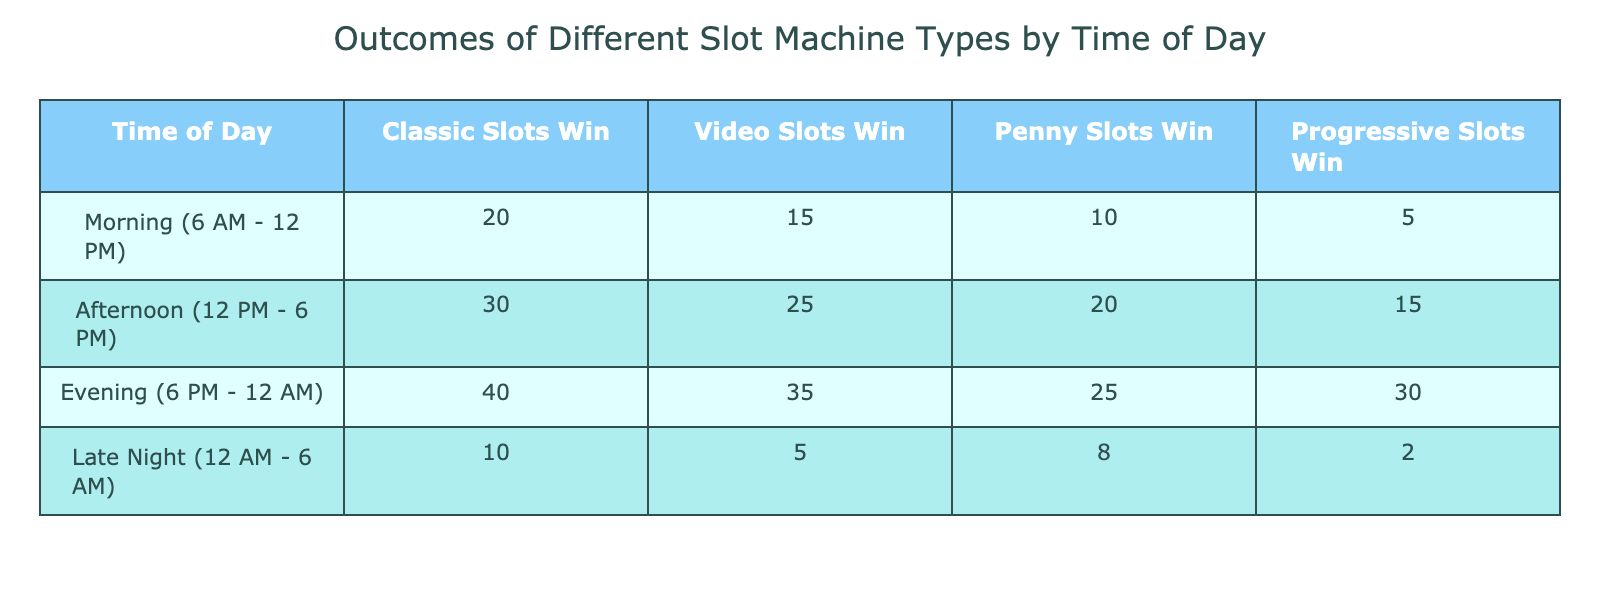What time of day has the highest winnings for Classic Slots? The table shows that the Evening (6 PM - 12 AM) slot has the highest winning of 40 for Classic Slots.
Answer: Evening (6 PM - 12 AM) Which type of slot machine had the lowest winnings during the Late Night? Looking at the Late Night row, Progressive Slots has the lowest winnings with a value of 2.
Answer: Progressive Slots What is the total winnings for Video Slots during the Morning and Afternoon? To find the total winnings for Video Slots during these times, we add the Morning winnings (15) to the Afternoon winnings (25), resulting in 15 + 25 = 40.
Answer: 40 Is there any time of day when Penny Slots winnings exceeded Classic Slots winnings? By checking the values, the highest for Penny Slots is 25 during the Evening, while Classic Slots winnings during that time is 40, meaning Penny Slots never exceed Classic Slots winnings.
Answer: No What is the average winnings across all types of slots during the Afternoon? To find the average winnings, we add the winnings for all slot types in the Afternoon: 30 (Classic) + 25 (Video) + 20 (Penny) + 15 (Progressive) = 90. Then, dividing by the number of slot types (4), we get 90 / 4 = 22.5.
Answer: 22.5 During which time of day is the total winnings for all slot types the lowest? First, we calculate the total winnings for each time of day: Morning = 20 + 15 + 10 + 5 = 50, Afternoon = 30 + 25 + 20 + 15 = 90, Evening = 40 + 35 + 25 + 30 = 130, Late Night = 10 + 5 + 8 + 2 = 25. Late Night has the lowest total winnings with 25.
Answer: Late Night (12 AM - 6 AM) How much higher are the winnings of Classic Slots in the Evening compared to the Morning? The winnings for Classic Slots in the Evening are 40, while in the Morning they are 20. The difference is 40 - 20 = 20.
Answer: 20 Is the total winnings for Progressive Slots greater during the Afternoon compared to the Morning? The Progressive Slots winnings are 15 during the Afternoon and 5 during the Morning. Since 15 is greater than 5, the statement is true.
Answer: Yes 